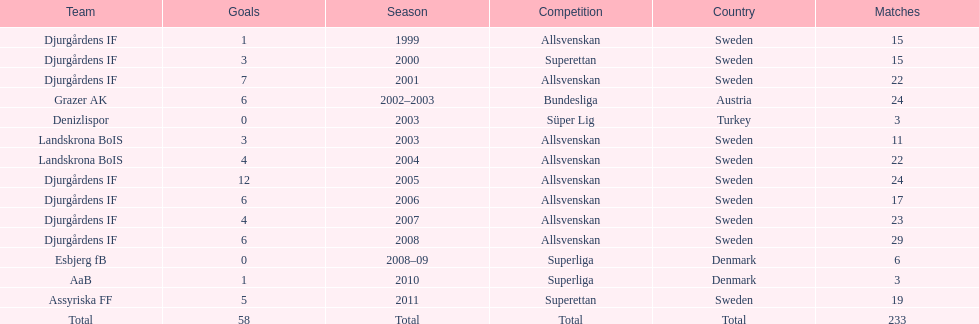What was the number of goals he scored in 2005? 12. 